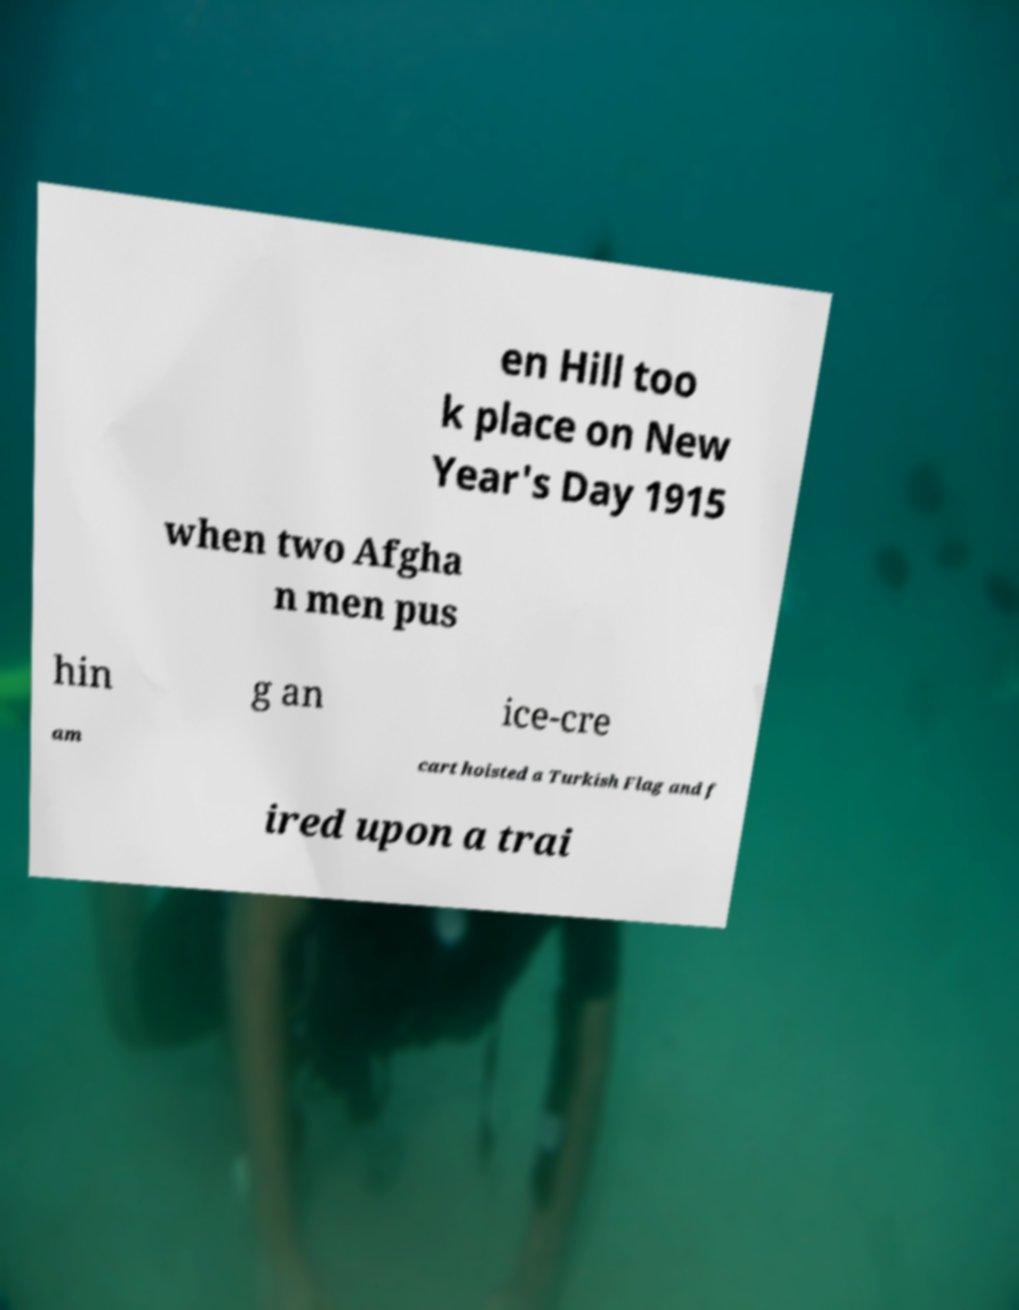Can you accurately transcribe the text from the provided image for me? en Hill too k place on New Year's Day 1915 when two Afgha n men pus hin g an ice-cre am cart hoisted a Turkish Flag and f ired upon a trai 